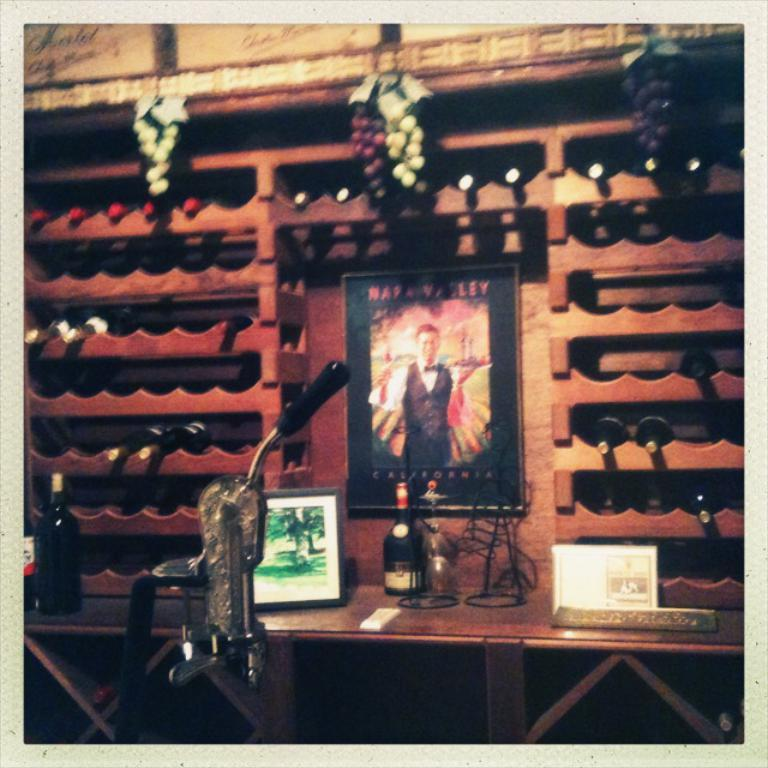<image>
Relay a brief, clear account of the picture shown. A poster with a man on it that says California at the bottom. 